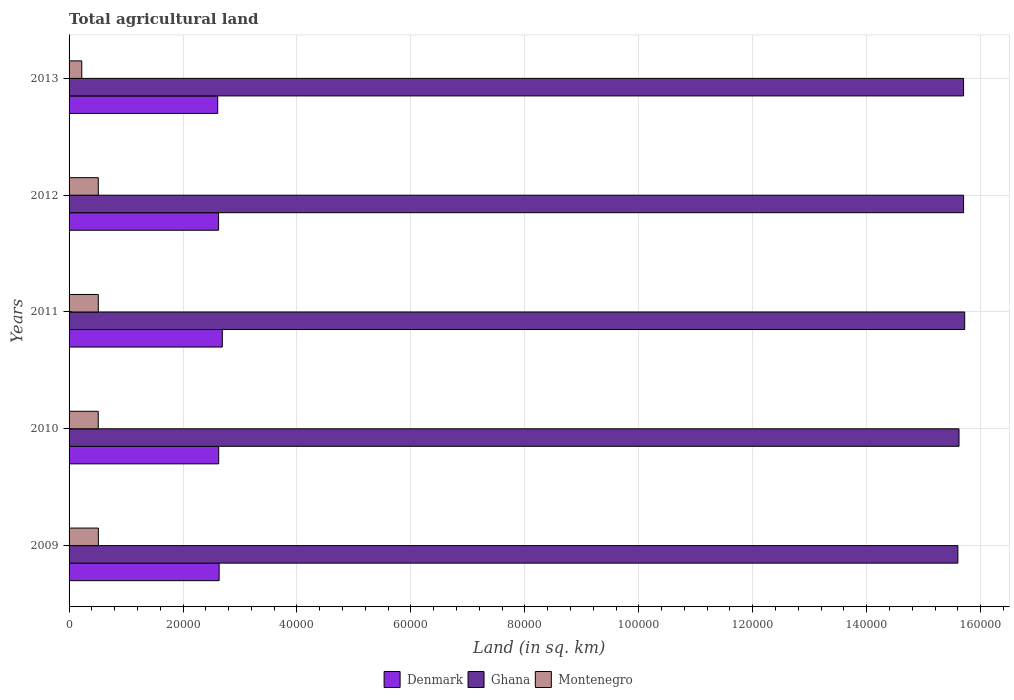How many different coloured bars are there?
Make the answer very short. 3. Are the number of bars on each tick of the Y-axis equal?
Your answer should be compact. Yes. In how many cases, is the number of bars for a given year not equal to the number of legend labels?
Provide a short and direct response. 0. What is the total agricultural land in Montenegro in 2009?
Offer a terse response. 5140. Across all years, what is the maximum total agricultural land in Montenegro?
Give a very brief answer. 5140. Across all years, what is the minimum total agricultural land in Ghana?
Give a very brief answer. 1.56e+05. In which year was the total agricultural land in Denmark minimum?
Keep it short and to the point. 2013. What is the total total agricultural land in Denmark in the graph?
Offer a terse response. 1.32e+05. What is the difference between the total agricultural land in Montenegro in 2011 and that in 2013?
Ensure brevity in your answer.  2898.7. What is the difference between the total agricultural land in Ghana in 2009 and the total agricultural land in Montenegro in 2013?
Ensure brevity in your answer.  1.54e+05. What is the average total agricultural land in Montenegro per year?
Offer a terse response. 4550.26. In the year 2012, what is the difference between the total agricultural land in Ghana and total agricultural land in Denmark?
Provide a succinct answer. 1.31e+05. In how many years, is the total agricultural land in Denmark greater than 136000 sq.km?
Your response must be concise. 0. What is the ratio of the total agricultural land in Montenegro in 2010 to that in 2013?
Provide a short and direct response. 2.29. Is the total agricultural land in Denmark in 2010 less than that in 2011?
Ensure brevity in your answer.  Yes. What is the difference between the highest and the lowest total agricultural land in Denmark?
Make the answer very short. 810. In how many years, is the total agricultural land in Ghana greater than the average total agricultural land in Ghana taken over all years?
Offer a terse response. 3. Is it the case that in every year, the sum of the total agricultural land in Ghana and total agricultural land in Denmark is greater than the total agricultural land in Montenegro?
Keep it short and to the point. Yes. What is the difference between two consecutive major ticks on the X-axis?
Provide a succinct answer. 2.00e+04. Does the graph contain any zero values?
Make the answer very short. No. Where does the legend appear in the graph?
Offer a very short reply. Bottom center. How many legend labels are there?
Give a very brief answer. 3. How are the legend labels stacked?
Your response must be concise. Horizontal. What is the title of the graph?
Offer a terse response. Total agricultural land. What is the label or title of the X-axis?
Your response must be concise. Land (in sq. km). What is the Land (in sq. km) of Denmark in 2009?
Your answer should be compact. 2.63e+04. What is the Land (in sq. km) in Ghana in 2009?
Give a very brief answer. 1.56e+05. What is the Land (in sq. km) of Montenegro in 2009?
Your response must be concise. 5140. What is the Land (in sq. km) of Denmark in 2010?
Give a very brief answer. 2.63e+04. What is the Land (in sq. km) of Ghana in 2010?
Keep it short and to the point. 1.56e+05. What is the Land (in sq. km) of Montenegro in 2010?
Provide a succinct answer. 5120. What is the Land (in sq. km) of Denmark in 2011?
Make the answer very short. 2.69e+04. What is the Land (in sq. km) in Ghana in 2011?
Keep it short and to the point. 1.57e+05. What is the Land (in sq. km) in Montenegro in 2011?
Provide a short and direct response. 5130. What is the Land (in sq. km) of Denmark in 2012?
Your response must be concise. 2.62e+04. What is the Land (in sq. km) of Ghana in 2012?
Offer a terse response. 1.57e+05. What is the Land (in sq. km) in Montenegro in 2012?
Provide a short and direct response. 5130. What is the Land (in sq. km) of Denmark in 2013?
Your answer should be very brief. 2.61e+04. What is the Land (in sq. km) of Ghana in 2013?
Make the answer very short. 1.57e+05. What is the Land (in sq. km) of Montenegro in 2013?
Your answer should be compact. 2231.3. Across all years, what is the maximum Land (in sq. km) of Denmark?
Your answer should be compact. 2.69e+04. Across all years, what is the maximum Land (in sq. km) of Ghana?
Give a very brief answer. 1.57e+05. Across all years, what is the maximum Land (in sq. km) of Montenegro?
Ensure brevity in your answer.  5140. Across all years, what is the minimum Land (in sq. km) in Denmark?
Offer a very short reply. 2.61e+04. Across all years, what is the minimum Land (in sq. km) in Ghana?
Your answer should be very brief. 1.56e+05. Across all years, what is the minimum Land (in sq. km) of Montenegro?
Ensure brevity in your answer.  2231.3. What is the total Land (in sq. km) in Denmark in the graph?
Offer a very short reply. 1.32e+05. What is the total Land (in sq. km) in Ghana in the graph?
Your answer should be compact. 7.83e+05. What is the total Land (in sq. km) of Montenegro in the graph?
Provide a short and direct response. 2.28e+04. What is the difference between the Land (in sq. km) in Ghana in 2009 and that in 2010?
Your response must be concise. -200. What is the difference between the Land (in sq. km) of Denmark in 2009 and that in 2011?
Ensure brevity in your answer.  -560. What is the difference between the Land (in sq. km) of Ghana in 2009 and that in 2011?
Your answer should be compact. -1200. What is the difference between the Land (in sq. km) in Montenegro in 2009 and that in 2011?
Ensure brevity in your answer.  10. What is the difference between the Land (in sq. km) of Ghana in 2009 and that in 2012?
Make the answer very short. -1000. What is the difference between the Land (in sq. km) in Denmark in 2009 and that in 2013?
Provide a short and direct response. 250. What is the difference between the Land (in sq. km) in Ghana in 2009 and that in 2013?
Your response must be concise. -1000. What is the difference between the Land (in sq. km) in Montenegro in 2009 and that in 2013?
Provide a succinct answer. 2908.7. What is the difference between the Land (in sq. km) in Denmark in 2010 and that in 2011?
Keep it short and to the point. -640. What is the difference between the Land (in sq. km) in Ghana in 2010 and that in 2011?
Ensure brevity in your answer.  -1000. What is the difference between the Land (in sq. km) of Montenegro in 2010 and that in 2011?
Provide a short and direct response. -10. What is the difference between the Land (in sq. km) of Denmark in 2010 and that in 2012?
Ensure brevity in your answer.  20. What is the difference between the Land (in sq. km) in Ghana in 2010 and that in 2012?
Make the answer very short. -800. What is the difference between the Land (in sq. km) in Montenegro in 2010 and that in 2012?
Offer a terse response. -10. What is the difference between the Land (in sq. km) in Denmark in 2010 and that in 2013?
Your answer should be very brief. 170. What is the difference between the Land (in sq. km) of Ghana in 2010 and that in 2013?
Keep it short and to the point. -800. What is the difference between the Land (in sq. km) of Montenegro in 2010 and that in 2013?
Offer a terse response. 2888.7. What is the difference between the Land (in sq. km) of Denmark in 2011 and that in 2012?
Your answer should be compact. 660. What is the difference between the Land (in sq. km) of Denmark in 2011 and that in 2013?
Provide a succinct answer. 810. What is the difference between the Land (in sq. km) of Ghana in 2011 and that in 2013?
Provide a succinct answer. 200. What is the difference between the Land (in sq. km) in Montenegro in 2011 and that in 2013?
Your response must be concise. 2898.7. What is the difference between the Land (in sq. km) in Denmark in 2012 and that in 2013?
Your answer should be very brief. 150. What is the difference between the Land (in sq. km) of Montenegro in 2012 and that in 2013?
Your answer should be compact. 2898.7. What is the difference between the Land (in sq. km) of Denmark in 2009 and the Land (in sq. km) of Ghana in 2010?
Your answer should be very brief. -1.30e+05. What is the difference between the Land (in sq. km) of Denmark in 2009 and the Land (in sq. km) of Montenegro in 2010?
Keep it short and to the point. 2.12e+04. What is the difference between the Land (in sq. km) of Ghana in 2009 and the Land (in sq. km) of Montenegro in 2010?
Provide a short and direct response. 1.51e+05. What is the difference between the Land (in sq. km) in Denmark in 2009 and the Land (in sq. km) in Ghana in 2011?
Provide a short and direct response. -1.31e+05. What is the difference between the Land (in sq. km) in Denmark in 2009 and the Land (in sq. km) in Montenegro in 2011?
Provide a short and direct response. 2.12e+04. What is the difference between the Land (in sq. km) of Ghana in 2009 and the Land (in sq. km) of Montenegro in 2011?
Offer a very short reply. 1.51e+05. What is the difference between the Land (in sq. km) of Denmark in 2009 and the Land (in sq. km) of Ghana in 2012?
Your answer should be compact. -1.31e+05. What is the difference between the Land (in sq. km) in Denmark in 2009 and the Land (in sq. km) in Montenegro in 2012?
Give a very brief answer. 2.12e+04. What is the difference between the Land (in sq. km) of Ghana in 2009 and the Land (in sq. km) of Montenegro in 2012?
Keep it short and to the point. 1.51e+05. What is the difference between the Land (in sq. km) of Denmark in 2009 and the Land (in sq. km) of Ghana in 2013?
Provide a succinct answer. -1.31e+05. What is the difference between the Land (in sq. km) of Denmark in 2009 and the Land (in sq. km) of Montenegro in 2013?
Offer a terse response. 2.41e+04. What is the difference between the Land (in sq. km) of Ghana in 2009 and the Land (in sq. km) of Montenegro in 2013?
Make the answer very short. 1.54e+05. What is the difference between the Land (in sq. km) of Denmark in 2010 and the Land (in sq. km) of Ghana in 2011?
Ensure brevity in your answer.  -1.31e+05. What is the difference between the Land (in sq. km) of Denmark in 2010 and the Land (in sq. km) of Montenegro in 2011?
Keep it short and to the point. 2.11e+04. What is the difference between the Land (in sq. km) in Ghana in 2010 and the Land (in sq. km) in Montenegro in 2011?
Your answer should be compact. 1.51e+05. What is the difference between the Land (in sq. km) in Denmark in 2010 and the Land (in sq. km) in Ghana in 2012?
Offer a terse response. -1.31e+05. What is the difference between the Land (in sq. km) in Denmark in 2010 and the Land (in sq. km) in Montenegro in 2012?
Your response must be concise. 2.11e+04. What is the difference between the Land (in sq. km) in Ghana in 2010 and the Land (in sq. km) in Montenegro in 2012?
Give a very brief answer. 1.51e+05. What is the difference between the Land (in sq. km) of Denmark in 2010 and the Land (in sq. km) of Ghana in 2013?
Ensure brevity in your answer.  -1.31e+05. What is the difference between the Land (in sq. km) in Denmark in 2010 and the Land (in sq. km) in Montenegro in 2013?
Provide a succinct answer. 2.40e+04. What is the difference between the Land (in sq. km) in Ghana in 2010 and the Land (in sq. km) in Montenegro in 2013?
Your answer should be compact. 1.54e+05. What is the difference between the Land (in sq. km) of Denmark in 2011 and the Land (in sq. km) of Ghana in 2012?
Provide a succinct answer. -1.30e+05. What is the difference between the Land (in sq. km) of Denmark in 2011 and the Land (in sq. km) of Montenegro in 2012?
Your answer should be very brief. 2.18e+04. What is the difference between the Land (in sq. km) of Ghana in 2011 and the Land (in sq. km) of Montenegro in 2012?
Your response must be concise. 1.52e+05. What is the difference between the Land (in sq. km) of Denmark in 2011 and the Land (in sq. km) of Ghana in 2013?
Offer a terse response. -1.30e+05. What is the difference between the Land (in sq. km) in Denmark in 2011 and the Land (in sq. km) in Montenegro in 2013?
Make the answer very short. 2.47e+04. What is the difference between the Land (in sq. km) in Ghana in 2011 and the Land (in sq. km) in Montenegro in 2013?
Your answer should be compact. 1.55e+05. What is the difference between the Land (in sq. km) of Denmark in 2012 and the Land (in sq. km) of Ghana in 2013?
Keep it short and to the point. -1.31e+05. What is the difference between the Land (in sq. km) in Denmark in 2012 and the Land (in sq. km) in Montenegro in 2013?
Give a very brief answer. 2.40e+04. What is the difference between the Land (in sq. km) in Ghana in 2012 and the Land (in sq. km) in Montenegro in 2013?
Make the answer very short. 1.55e+05. What is the average Land (in sq. km) of Denmark per year?
Your answer should be compact. 2.64e+04. What is the average Land (in sq. km) of Ghana per year?
Ensure brevity in your answer.  1.57e+05. What is the average Land (in sq. km) in Montenegro per year?
Your response must be concise. 4550.26. In the year 2009, what is the difference between the Land (in sq. km) in Denmark and Land (in sq. km) in Ghana?
Your response must be concise. -1.30e+05. In the year 2009, what is the difference between the Land (in sq. km) in Denmark and Land (in sq. km) in Montenegro?
Ensure brevity in your answer.  2.12e+04. In the year 2009, what is the difference between the Land (in sq. km) of Ghana and Land (in sq. km) of Montenegro?
Ensure brevity in your answer.  1.51e+05. In the year 2010, what is the difference between the Land (in sq. km) in Denmark and Land (in sq. km) in Ghana?
Provide a short and direct response. -1.30e+05. In the year 2010, what is the difference between the Land (in sq. km) in Denmark and Land (in sq. km) in Montenegro?
Keep it short and to the point. 2.11e+04. In the year 2010, what is the difference between the Land (in sq. km) in Ghana and Land (in sq. km) in Montenegro?
Your answer should be compact. 1.51e+05. In the year 2011, what is the difference between the Land (in sq. km) of Denmark and Land (in sq. km) of Ghana?
Your answer should be compact. -1.30e+05. In the year 2011, what is the difference between the Land (in sq. km) in Denmark and Land (in sq. km) in Montenegro?
Your answer should be compact. 2.18e+04. In the year 2011, what is the difference between the Land (in sq. km) in Ghana and Land (in sq. km) in Montenegro?
Make the answer very short. 1.52e+05. In the year 2012, what is the difference between the Land (in sq. km) of Denmark and Land (in sq. km) of Ghana?
Offer a very short reply. -1.31e+05. In the year 2012, what is the difference between the Land (in sq. km) in Denmark and Land (in sq. km) in Montenegro?
Ensure brevity in your answer.  2.11e+04. In the year 2012, what is the difference between the Land (in sq. km) of Ghana and Land (in sq. km) of Montenegro?
Your answer should be very brief. 1.52e+05. In the year 2013, what is the difference between the Land (in sq. km) in Denmark and Land (in sq. km) in Ghana?
Provide a short and direct response. -1.31e+05. In the year 2013, what is the difference between the Land (in sq. km) in Denmark and Land (in sq. km) in Montenegro?
Ensure brevity in your answer.  2.39e+04. In the year 2013, what is the difference between the Land (in sq. km) in Ghana and Land (in sq. km) in Montenegro?
Your answer should be compact. 1.55e+05. What is the ratio of the Land (in sq. km) in Ghana in 2009 to that in 2010?
Your response must be concise. 1. What is the ratio of the Land (in sq. km) in Denmark in 2009 to that in 2011?
Your response must be concise. 0.98. What is the ratio of the Land (in sq. km) of Ghana in 2009 to that in 2012?
Ensure brevity in your answer.  0.99. What is the ratio of the Land (in sq. km) of Denmark in 2009 to that in 2013?
Your answer should be very brief. 1.01. What is the ratio of the Land (in sq. km) in Ghana in 2009 to that in 2013?
Offer a terse response. 0.99. What is the ratio of the Land (in sq. km) in Montenegro in 2009 to that in 2013?
Provide a succinct answer. 2.3. What is the ratio of the Land (in sq. km) in Denmark in 2010 to that in 2011?
Your response must be concise. 0.98. What is the ratio of the Land (in sq. km) of Ghana in 2010 to that in 2011?
Your answer should be very brief. 0.99. What is the ratio of the Land (in sq. km) of Montenegro in 2010 to that in 2013?
Make the answer very short. 2.29. What is the ratio of the Land (in sq. km) of Denmark in 2011 to that in 2012?
Keep it short and to the point. 1.03. What is the ratio of the Land (in sq. km) of Denmark in 2011 to that in 2013?
Offer a terse response. 1.03. What is the ratio of the Land (in sq. km) in Ghana in 2011 to that in 2013?
Provide a succinct answer. 1. What is the ratio of the Land (in sq. km) of Montenegro in 2011 to that in 2013?
Keep it short and to the point. 2.3. What is the ratio of the Land (in sq. km) of Denmark in 2012 to that in 2013?
Your answer should be very brief. 1.01. What is the ratio of the Land (in sq. km) of Ghana in 2012 to that in 2013?
Make the answer very short. 1. What is the ratio of the Land (in sq. km) of Montenegro in 2012 to that in 2013?
Provide a short and direct response. 2.3. What is the difference between the highest and the second highest Land (in sq. km) of Denmark?
Ensure brevity in your answer.  560. What is the difference between the highest and the second highest Land (in sq. km) in Ghana?
Offer a very short reply. 200. What is the difference between the highest and the lowest Land (in sq. km) in Denmark?
Offer a very short reply. 810. What is the difference between the highest and the lowest Land (in sq. km) in Ghana?
Provide a succinct answer. 1200. What is the difference between the highest and the lowest Land (in sq. km) of Montenegro?
Your response must be concise. 2908.7. 